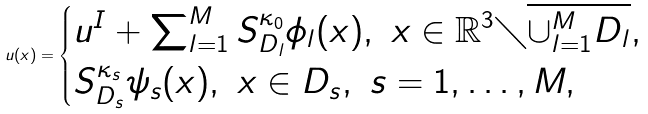Convert formula to latex. <formula><loc_0><loc_0><loc_500><loc_500>u ( x ) = \begin{cases} u ^ { I } + \sum ^ { M } _ { l = 1 } S ^ { \kappa _ { 0 } } _ { D _ { l } } \phi _ { l } ( x ) , \ x \in \mathbb { R } ^ { 3 } \diagdown \overline { \cup _ { l = 1 } ^ { M } D _ { l } } , \\ S ^ { \kappa _ { s } } _ { D _ { s } } \psi _ { s } ( x ) , \ x \in D _ { s } , \ s = 1 , \dots , M , \end{cases}</formula> 